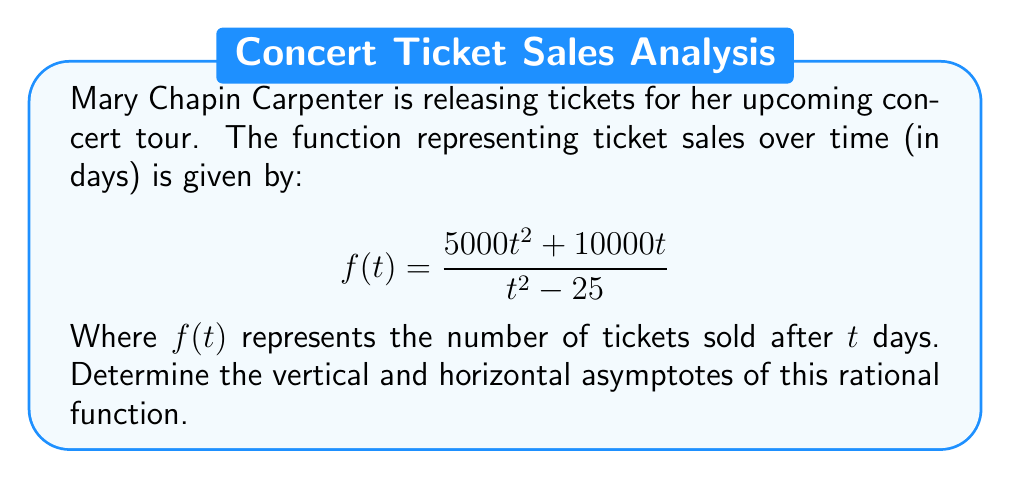Give your solution to this math problem. To find the asymptotes of this rational function, we'll follow these steps:

1) Vertical asymptotes:
   Vertical asymptotes occur when the denominator equals zero.
   Set $t^2 - 25 = 0$
   $t^2 = 25$
   $t = \pm 5$
   So, vertical asymptotes occur at $t = 5$ and $t = -5$

2) Horizontal asymptote:
   To find the horizontal asymptote, we compare the degrees of the numerator and denominator.
   Degree of numerator = 2
   Degree of denominator = 2
   Since they're equal, the horizontal asymptote will be the ratio of the leading coefficients.

   Leading coefficient of numerator: 5000
   Leading coefficient of denominator: 1

   Therefore, the horizontal asymptote is $y = 5000$

3) Interpretation:
   - The vertical asymptotes at $t = \pm 5$ indicate that the function is undefined 5 days before and after the ticket release date.
   - The horizontal asymptote at $y = 5000$ suggests that the total number of tickets available for the concert is likely 5000, which will be approached as time goes on.
Answer: Vertical asymptotes: $t = \pm 5$; Horizontal asymptote: $y = 5000$ 